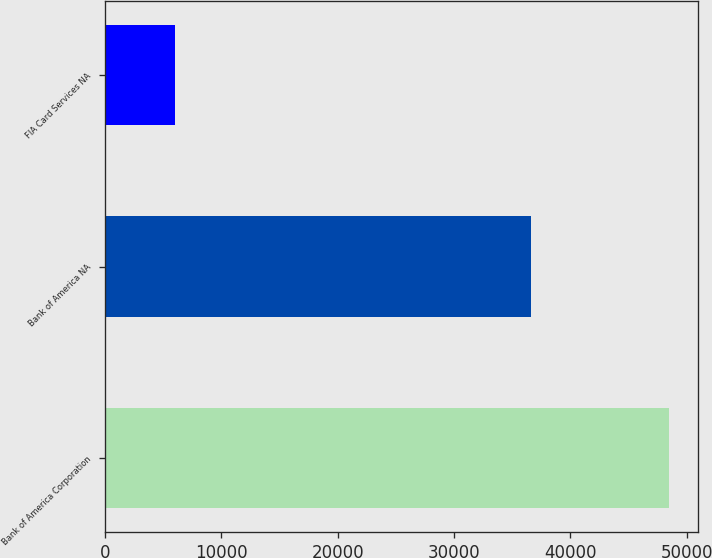Convert chart to OTSL. <chart><loc_0><loc_0><loc_500><loc_500><bar_chart><fcel>Bank of America Corporation<fcel>Bank of America NA<fcel>FIA Card Services NA<nl><fcel>48516<fcel>36661<fcel>6053<nl></chart> 